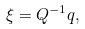<formula> <loc_0><loc_0><loc_500><loc_500>\xi = Q ^ { - 1 } q ,</formula> 